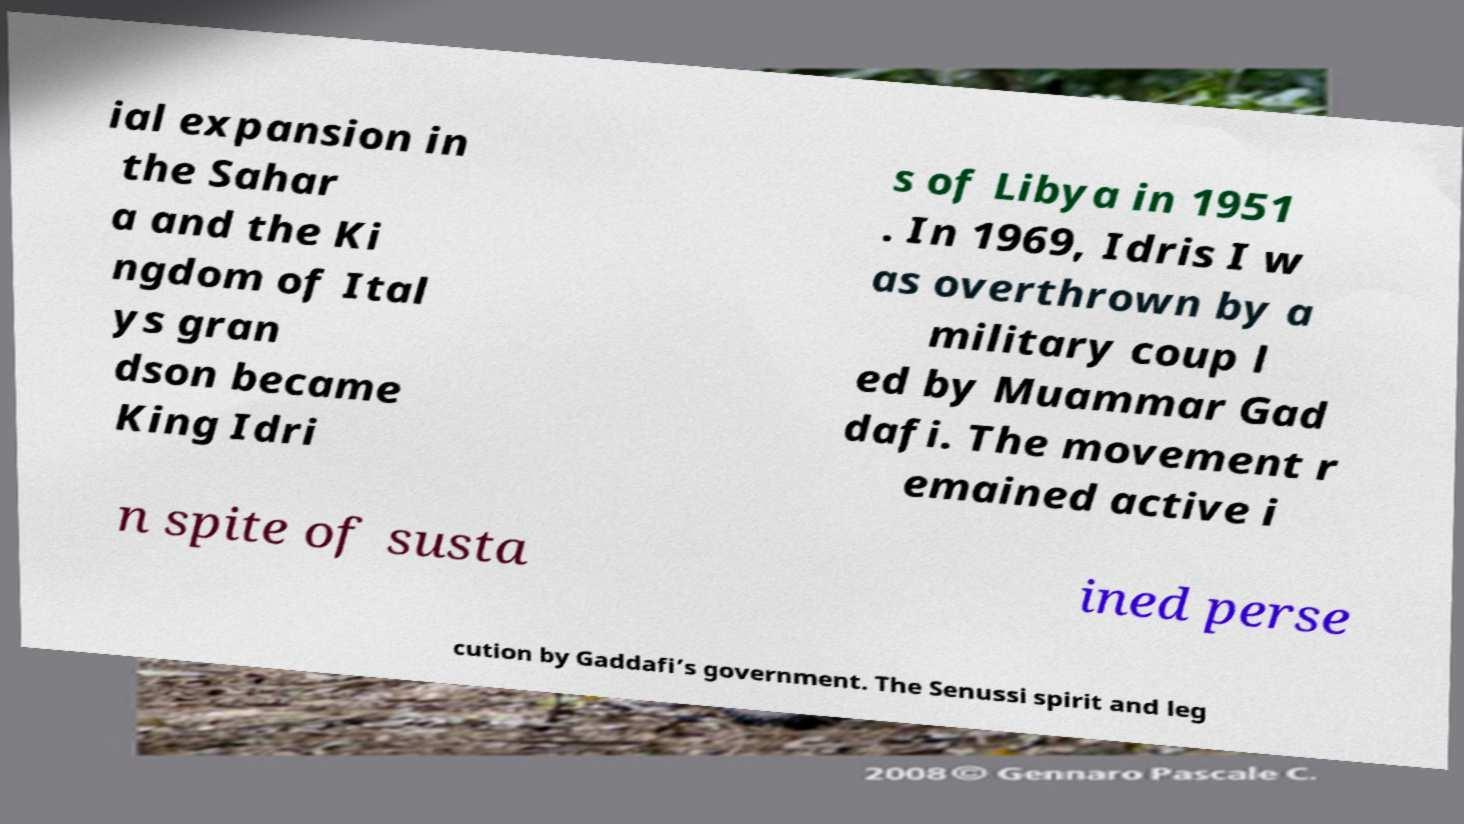Can you accurately transcribe the text from the provided image for me? ial expansion in the Sahar a and the Ki ngdom of Ital ys gran dson became King Idri s of Libya in 1951 . In 1969, Idris I w as overthrown by a military coup l ed by Muammar Gad dafi. The movement r emained active i n spite of susta ined perse cution by Gaddafi’s government. The Senussi spirit and leg 